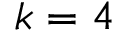Convert formula to latex. <formula><loc_0><loc_0><loc_500><loc_500>k = 4</formula> 